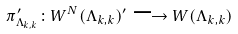Convert formula to latex. <formula><loc_0><loc_0><loc_500><loc_500>\pi _ { \Lambda _ { k , k } } ^ { \prime } \colon W ^ { N } ( \Lambda _ { k , k } ) ^ { \prime } \longrightarrow W ( \Lambda _ { k , k } )</formula> 